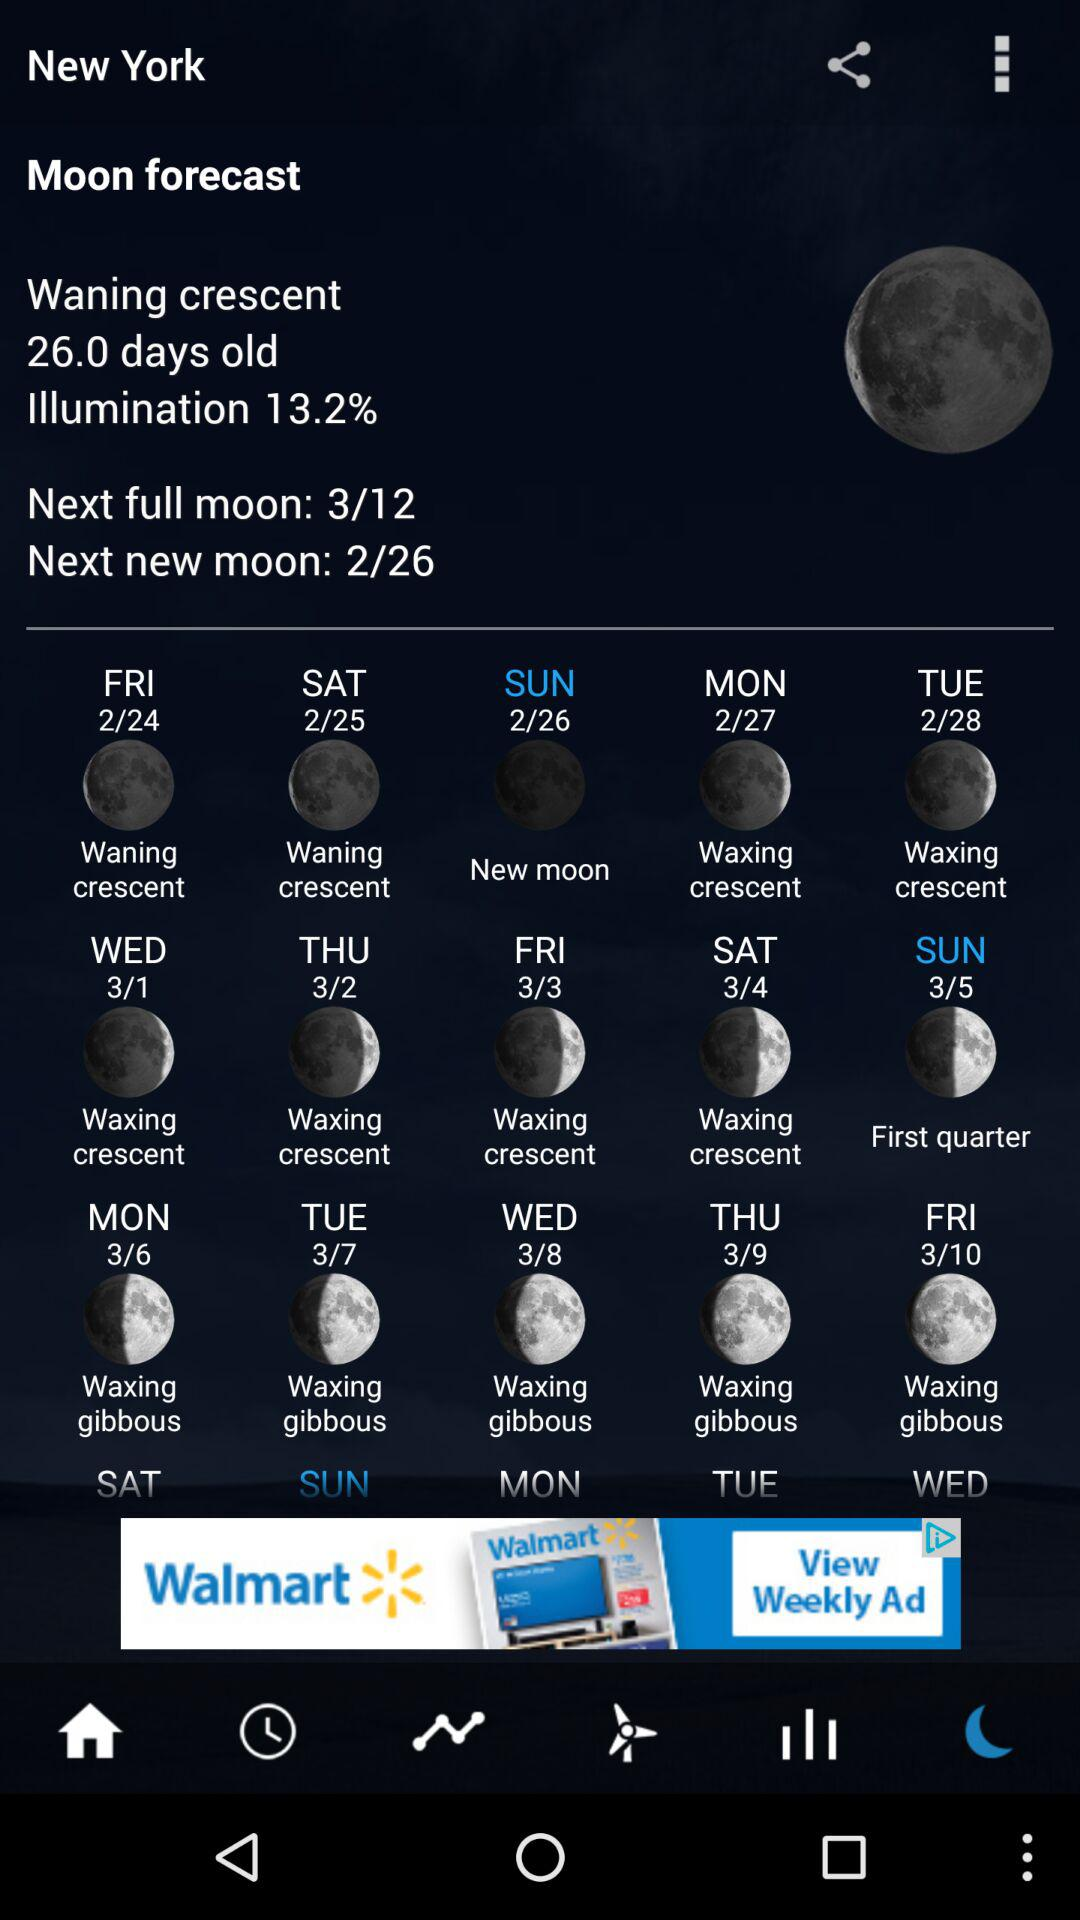How many days old is the waning crescent? The waning crescent is 26 days old. 